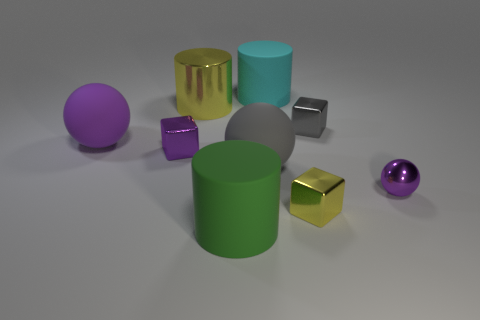Does the tiny cube that is in front of the tiny metallic ball have the same color as the shiny object behind the gray cube?
Provide a short and direct response. Yes. Is there anything else that has the same color as the large shiny thing?
Keep it short and to the point. Yes. What number of small gray shiny objects are the same shape as the cyan matte object?
Your response must be concise. 0. There is a metallic block in front of the large gray object; is its color the same as the big metal cylinder?
Make the answer very short. Yes. There is a yellow metal thing that is in front of the tiny shiny object on the left side of the rubber object that is behind the big purple sphere; what is its shape?
Ensure brevity in your answer.  Cube. There is a purple matte object; does it have the same size as the purple sphere that is to the right of the yellow block?
Your answer should be very brief. No. Are there any purple shiny cubes of the same size as the green rubber thing?
Your answer should be compact. No. How many other things are the same material as the tiny ball?
Keep it short and to the point. 4. What color is the thing that is behind the big gray sphere and to the right of the large cyan rubber cylinder?
Offer a very short reply. Gray. Do the yellow thing that is in front of the large purple ball and the large sphere that is to the left of the small purple block have the same material?
Provide a short and direct response. No. 